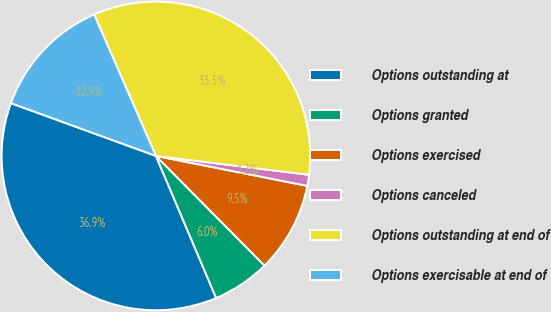Convert chart. <chart><loc_0><loc_0><loc_500><loc_500><pie_chart><fcel>Options outstanding at<fcel>Options granted<fcel>Options exercised<fcel>Options canceled<fcel>Options outstanding at end of<fcel>Options exercisable at end of<nl><fcel>36.94%<fcel>6.04%<fcel>9.47%<fcel>1.16%<fcel>33.51%<fcel>12.89%<nl></chart> 